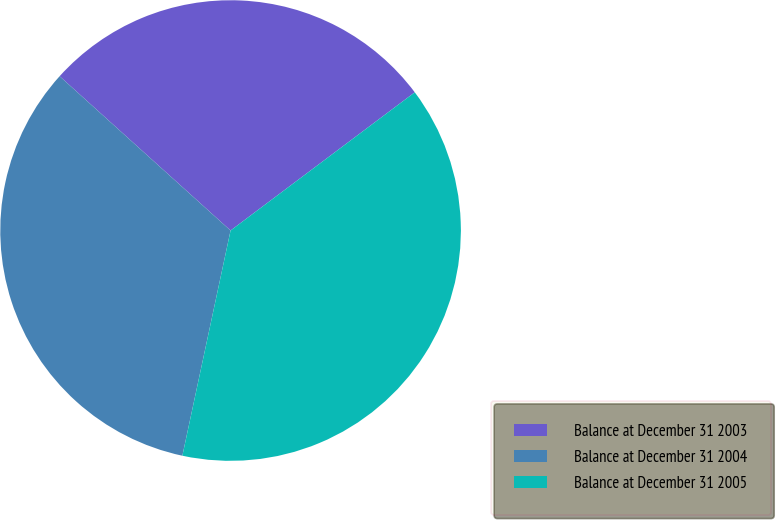<chart> <loc_0><loc_0><loc_500><loc_500><pie_chart><fcel>Balance at December 31 2003<fcel>Balance at December 31 2004<fcel>Balance at December 31 2005<nl><fcel>28.07%<fcel>33.33%<fcel>38.6%<nl></chart> 